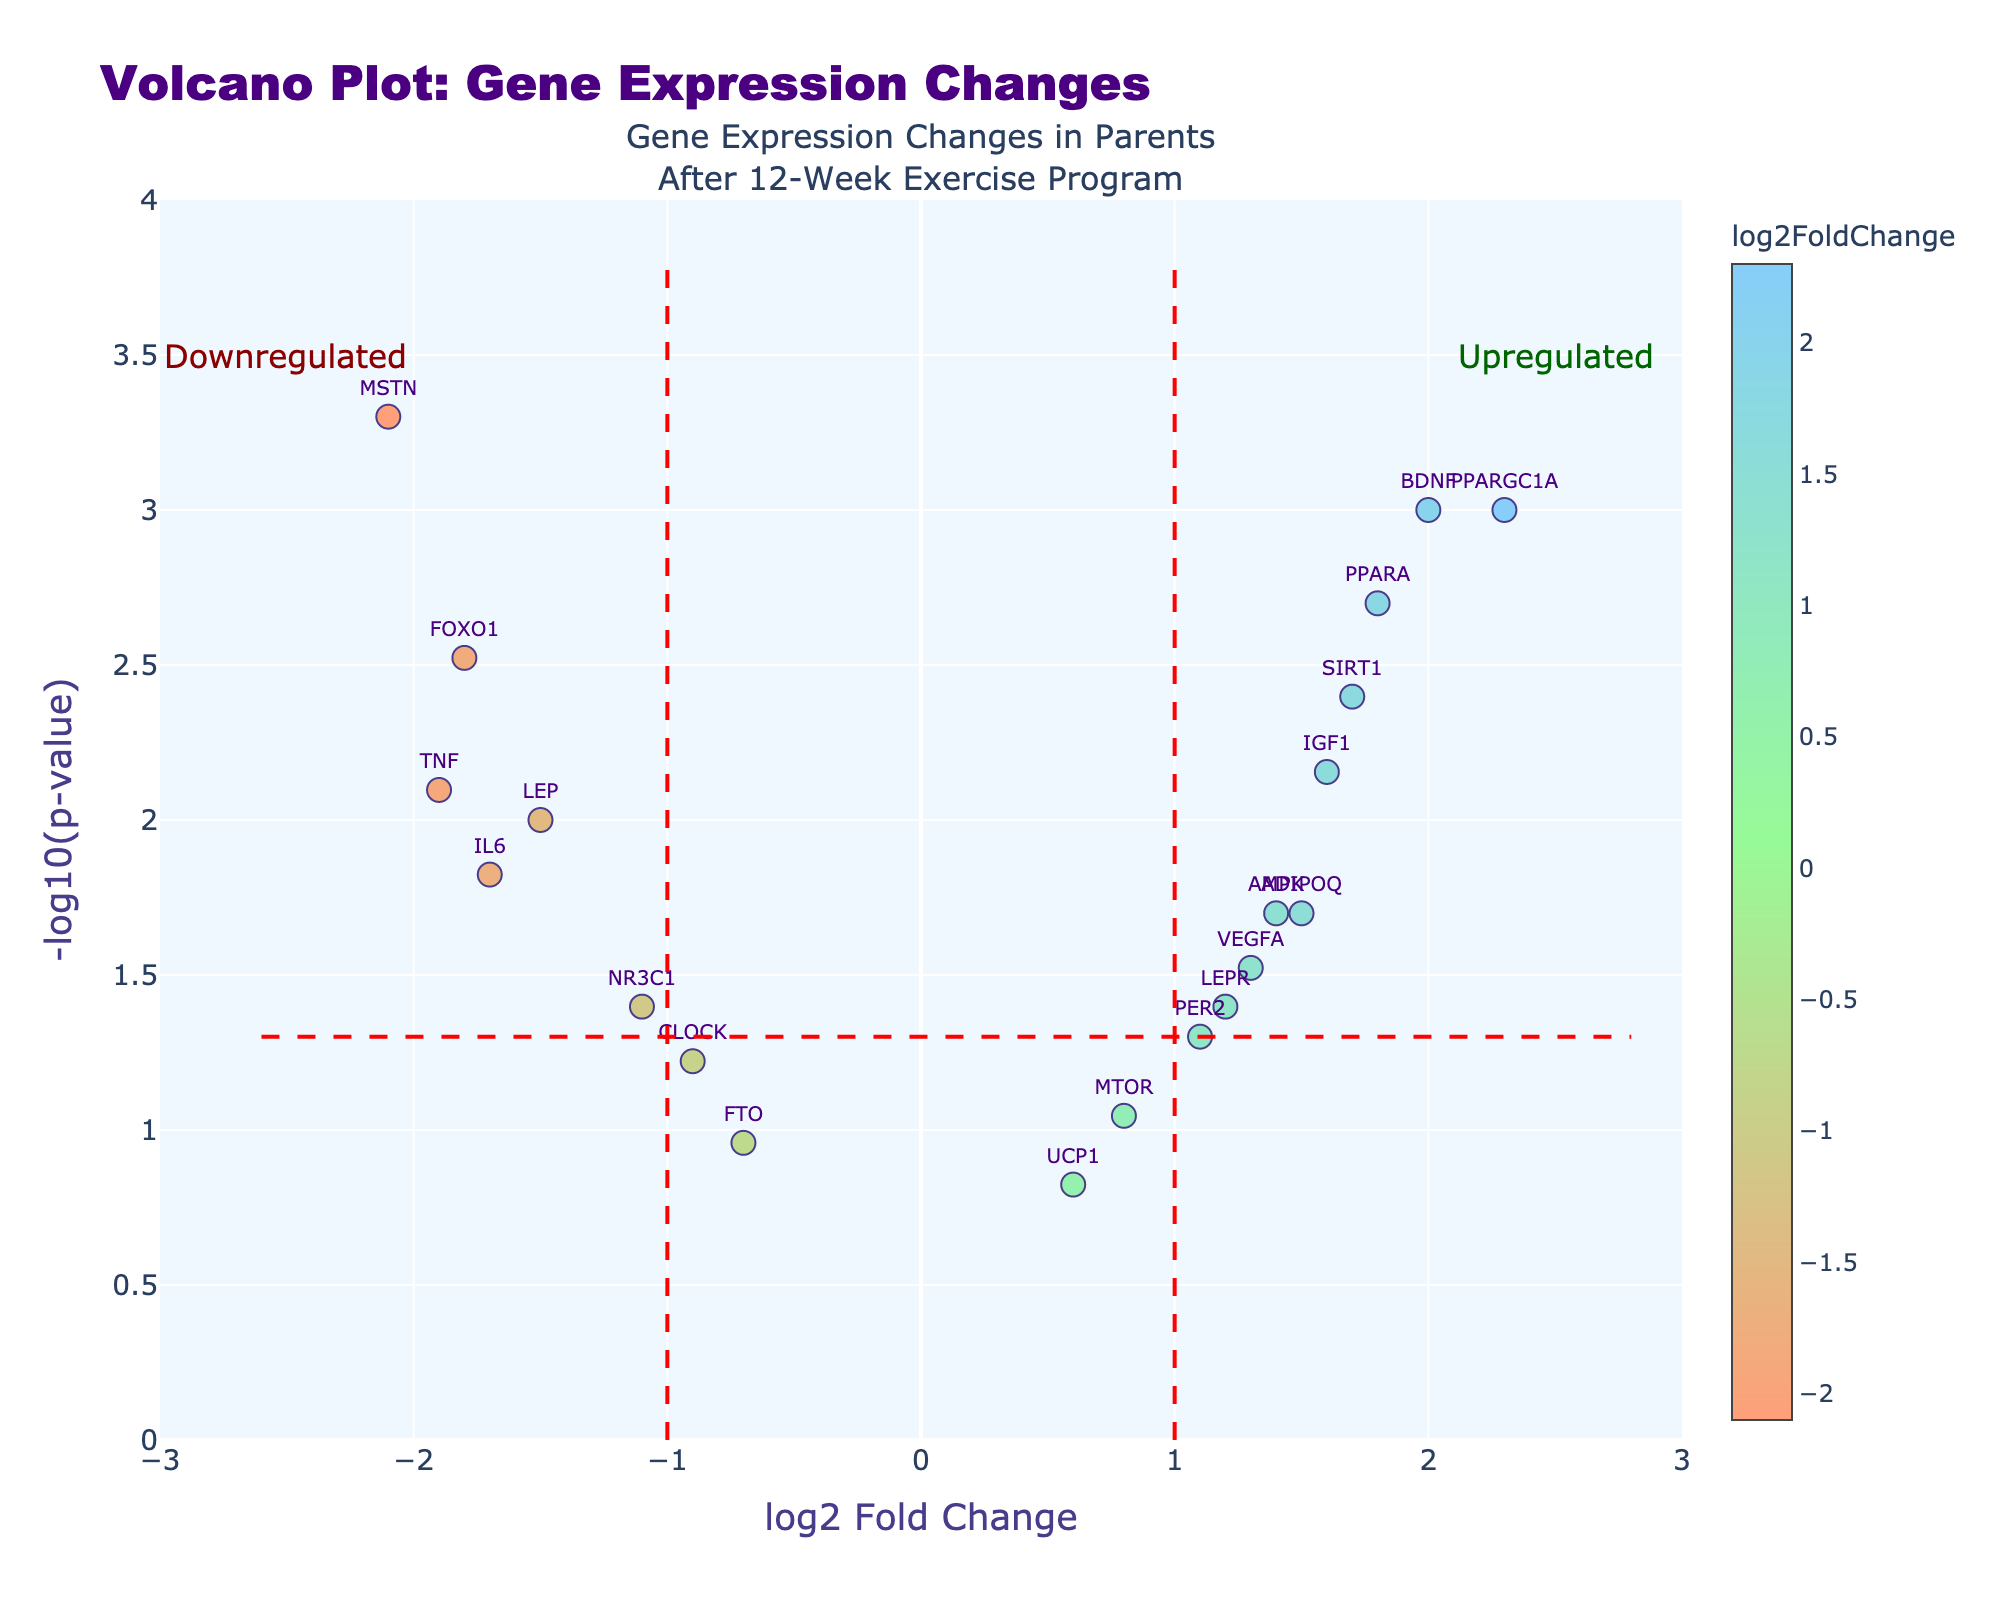What is the title of the plot? The title of the plot is usually displayed at the top of the figure. It summarizes the main topic of the plot. In this case, the title is "Volcano Plot: Gene Expression Changes".
Answer: Volcano Plot: Gene Expression Changes What is the range for the x-axis? The x-axis on the plot represents the log2 Fold Change and is usually labeled as such. Checking the values and the axis limits, the x-axis ranges from -3 to 3.
Answer: -3 to 3 How many genes are significantly downregulated (p-value < 0.05 and log2FoldChange < -1)? To determine this, we look for genes below the horizontal red line (indicating p-value < 0.05) and to the left of the vertical red line at log2FoldChange = -1. The significantly downregulated genes are FOXO1, MSTN, IL6, TNF, and LEP.
Answer: 5 Which gene has the highest log2 fold change? By looking at the position farthest to the right on the x-axis, we can see which gene has the highest log2 fold change. The gene PPARGC1A has the highest log2 fold change of 2.3.
Answer: PPARGC1A What are the genes that are both significantly upregulated and have a log2 fold change above 1? For this, we look for genes above the horizontal red line (indicating p-value < 0.05) and to the right of the vertical red line at log2FoldChange = 1. These genes are PPARGC1A, BDNF, PPAR, and SIRT1.
Answer: PPARGC1A, BDNF, PPAR, SIRT1 Which gene has the lowest p-value and what is its corresponding log2 fold change? By identifying the point with the highest y-value (the most significant gene), we can check the corresponding log2 fold change. The lowest p-value is for the gene MSTN with a log2 fold change of -2.1.
Answer: MSTN, -2.1 How many genes have a log2 fold change between -1 and 1? To find this, count the genes that lie between -1 and 1 on the x-axis, irrespective of their p-values. The relevant genes are CLOCK, PER2, MTOR, and UCP1, totaling to 4.
Answer: 4 Among the genes with a log2 fold change greater than 1.5, which one has the highest p-value? Look for genes with log2 fold change greater than 1.5 and compare their p-values. The relevant genes are PPARGC1A, BDNF, PPAR, and SIRT1. Among these, the gene with the highest p-value is SIRT1 with a p-value of 0.004.
Answer: SIRT1 What is the significance threshold for the p-values in the plot? The horizontal red line in the plot represents the significance threshold for p-values. This threshold is indicated by -log10(0.05) which equals approximately 1.3.
Answer: 1.3 